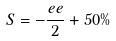Convert formula to latex. <formula><loc_0><loc_0><loc_500><loc_500>S = - \frac { e e } { 2 } + 5 0 \%</formula> 